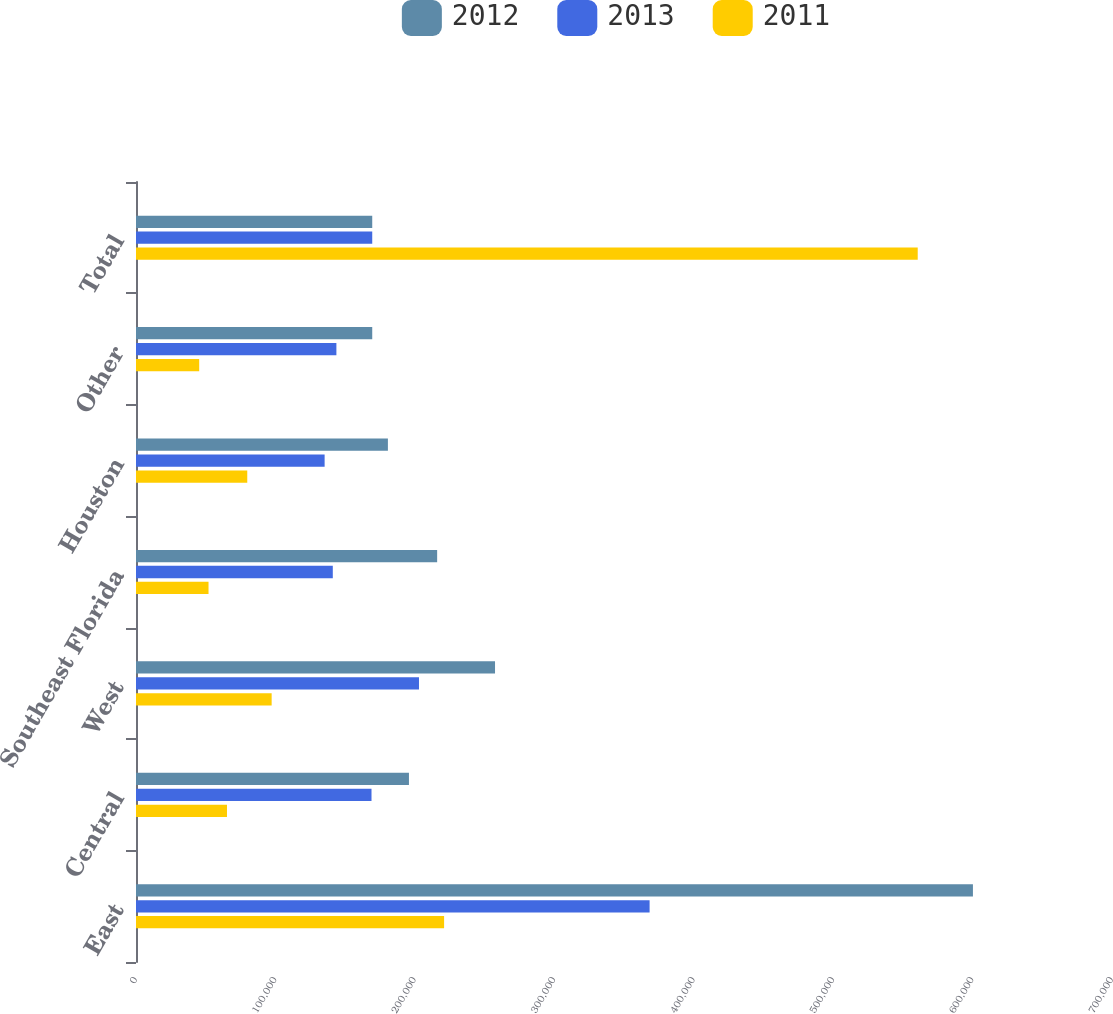<chart> <loc_0><loc_0><loc_500><loc_500><stacked_bar_chart><ecel><fcel>East<fcel>Central<fcel>West<fcel>Southeast Florida<fcel>Houston<fcel>Other<fcel>Total<nl><fcel>2012<fcel>600257<fcel>195762<fcel>257498<fcel>215988<fcel>180665<fcel>169431<fcel>169431<nl><fcel>2013<fcel>368361<fcel>168912<fcel>202959<fcel>141146<fcel>135282<fcel>143725<fcel>169431<nl><fcel>2011<fcel>220974<fcel>65256<fcel>97292<fcel>52013<fcel>79800<fcel>45324<fcel>560659<nl></chart> 